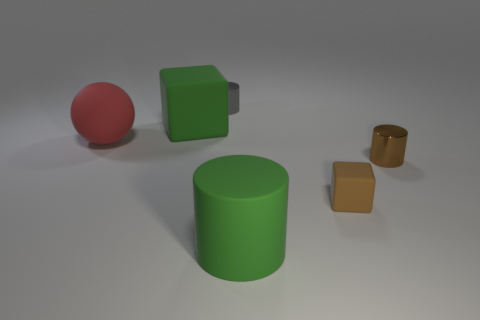Subtract all small cylinders. How many cylinders are left? 1 Add 4 cylinders. How many objects exist? 10 Subtract all balls. How many objects are left? 5 Subtract all green cylinders. How many cylinders are left? 2 Add 1 gray shiny cylinders. How many gray shiny cylinders are left? 2 Add 5 small cyan cylinders. How many small cyan cylinders exist? 5 Subtract 1 gray cylinders. How many objects are left? 5 Subtract all purple cylinders. Subtract all blue cubes. How many cylinders are left? 3 Subtract all tiny brown blocks. Subtract all big green rubber blocks. How many objects are left? 4 